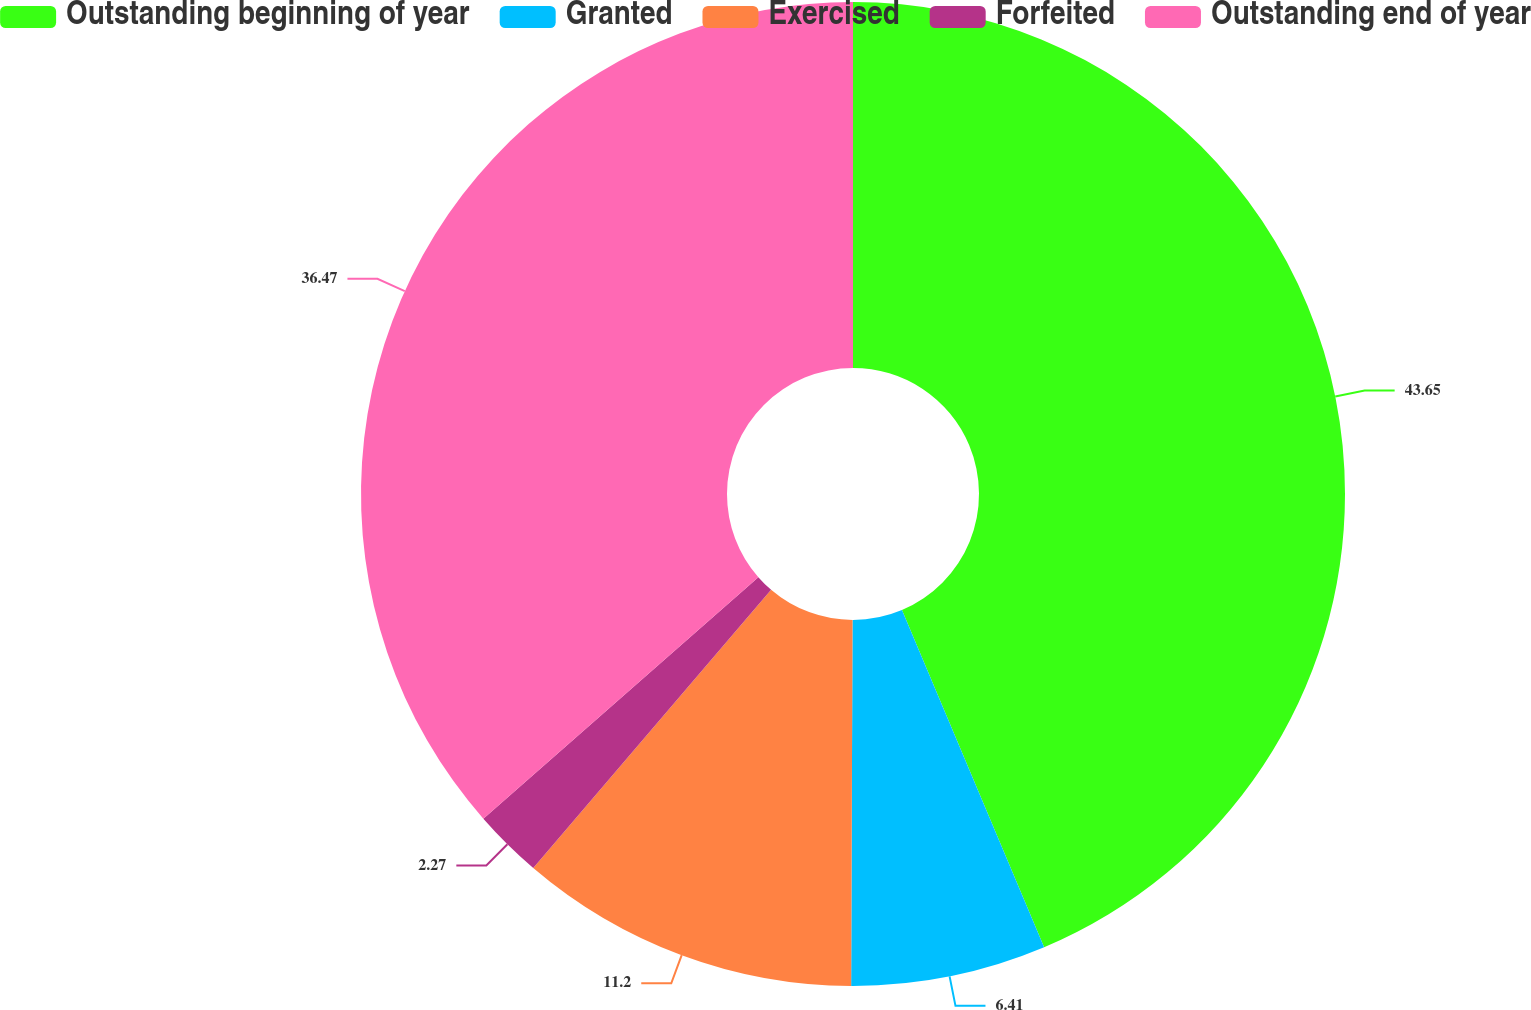Convert chart to OTSL. <chart><loc_0><loc_0><loc_500><loc_500><pie_chart><fcel>Outstanding beginning of year<fcel>Granted<fcel>Exercised<fcel>Forfeited<fcel>Outstanding end of year<nl><fcel>43.65%<fcel>6.41%<fcel>11.2%<fcel>2.27%<fcel>36.47%<nl></chart> 